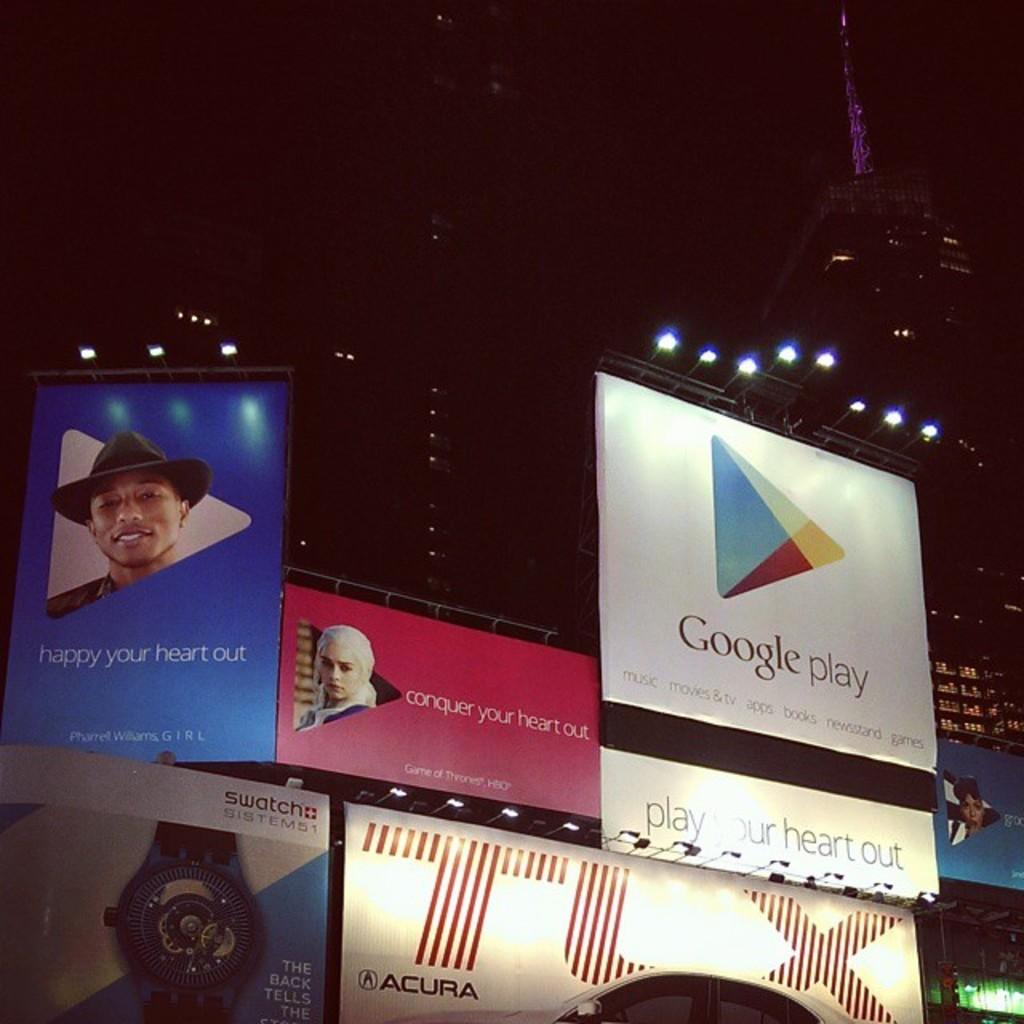Provide a one-sentence caption for the provided image. many signs are hanging up, including a google play ad. 